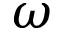Convert formula to latex. <formula><loc_0><loc_0><loc_500><loc_500>\omega</formula> 